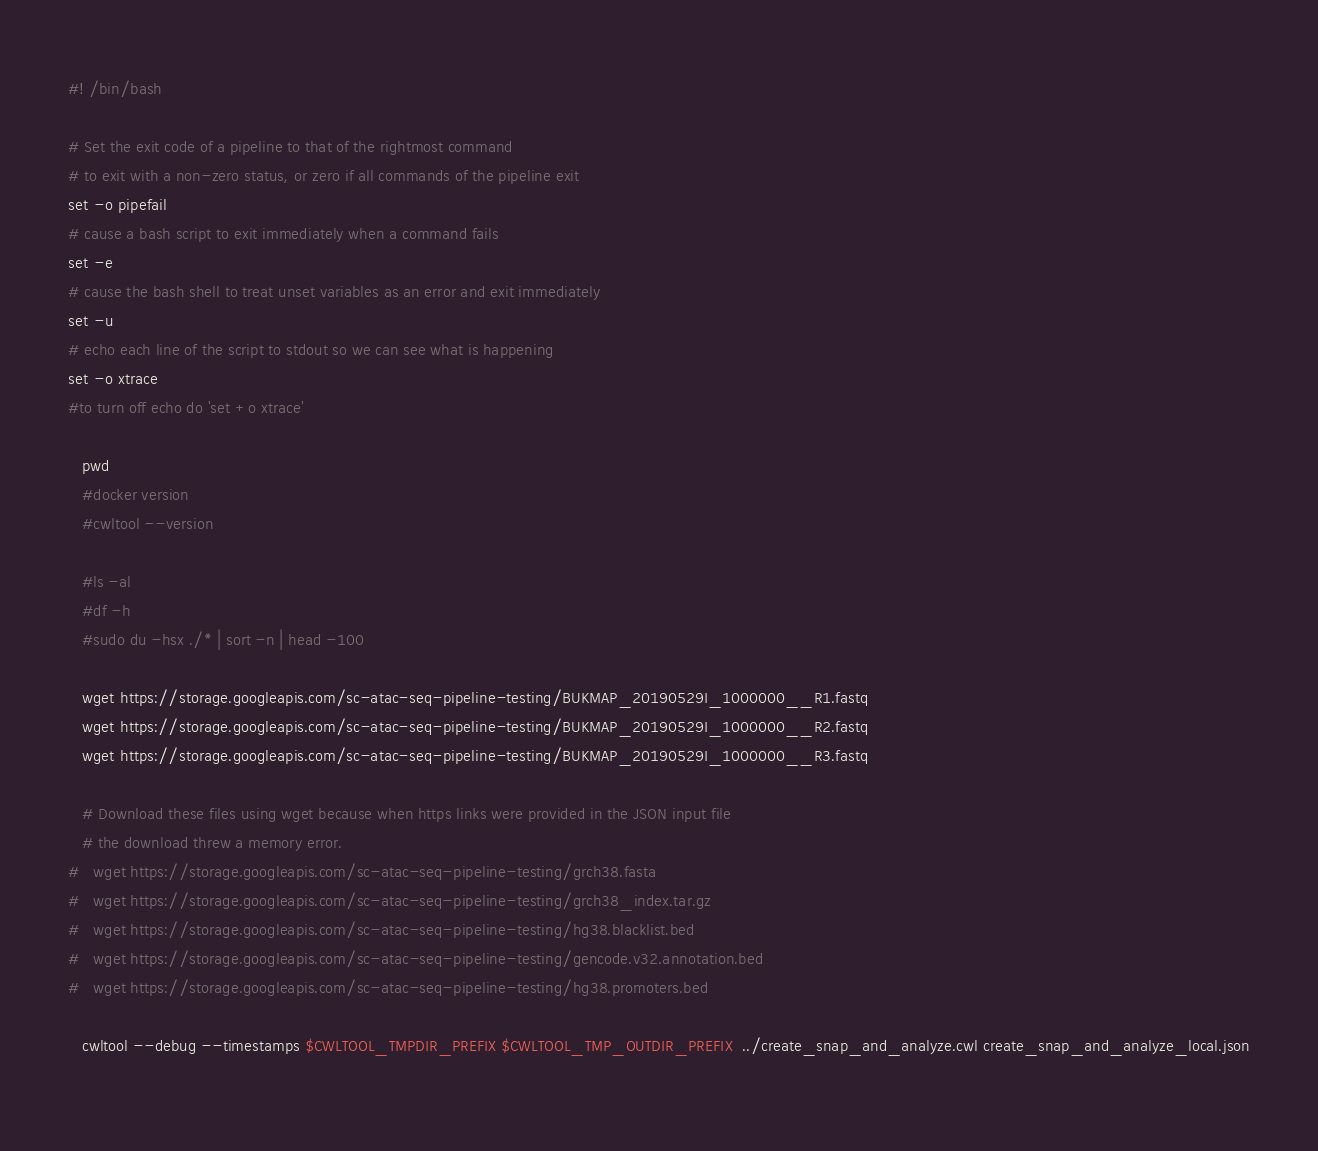<code> <loc_0><loc_0><loc_500><loc_500><_Bash_>#! /bin/bash

# Set the exit code of a pipeline to that of the rightmost command
# to exit with a non-zero status, or zero if all commands of the pipeline exit
set -o pipefail
# cause a bash script to exit immediately when a command fails
set -e
# cause the bash shell to treat unset variables as an error and exit immediately
set -u
# echo each line of the script to stdout so we can see what is happening
set -o xtrace
#to turn off echo do 'set +o xtrace'

   pwd
   #docker version
   #cwltool --version

   #ls -al
   #df -h
   #sudo du -hsx ./* | sort -n | head -100

   wget https://storage.googleapis.com/sc-atac-seq-pipeline-testing/BUKMAP_20190529I_1000000__R1.fastq
   wget https://storage.googleapis.com/sc-atac-seq-pipeline-testing/BUKMAP_20190529I_1000000__R2.fastq
   wget https://storage.googleapis.com/sc-atac-seq-pipeline-testing/BUKMAP_20190529I_1000000__R3.fastq

   # Download these files using wget because when https links were provided in the JSON input file
   # the download threw a memory error.
#   wget https://storage.googleapis.com/sc-atac-seq-pipeline-testing/grch38.fasta
#   wget https://storage.googleapis.com/sc-atac-seq-pipeline-testing/grch38_index.tar.gz
#   wget https://storage.googleapis.com/sc-atac-seq-pipeline-testing/hg38.blacklist.bed
#   wget https://storage.googleapis.com/sc-atac-seq-pipeline-testing/gencode.v32.annotation.bed
#   wget https://storage.googleapis.com/sc-atac-seq-pipeline-testing/hg38.promoters.bed

   cwltool --debug --timestamps $CWLTOOL_TMPDIR_PREFIX $CWLTOOL_TMP_OUTDIR_PREFIX  ../create_snap_and_analyze.cwl create_snap_and_analyze_local.json
  


</code> 